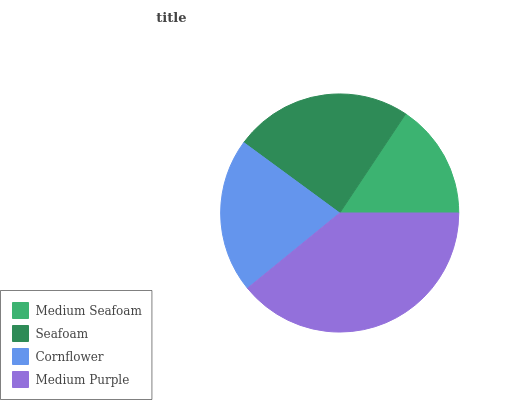Is Medium Seafoam the minimum?
Answer yes or no. Yes. Is Medium Purple the maximum?
Answer yes or no. Yes. Is Seafoam the minimum?
Answer yes or no. No. Is Seafoam the maximum?
Answer yes or no. No. Is Seafoam greater than Medium Seafoam?
Answer yes or no. Yes. Is Medium Seafoam less than Seafoam?
Answer yes or no. Yes. Is Medium Seafoam greater than Seafoam?
Answer yes or no. No. Is Seafoam less than Medium Seafoam?
Answer yes or no. No. Is Seafoam the high median?
Answer yes or no. Yes. Is Cornflower the low median?
Answer yes or no. Yes. Is Medium Seafoam the high median?
Answer yes or no. No. Is Seafoam the low median?
Answer yes or no. No. 